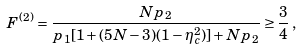<formula> <loc_0><loc_0><loc_500><loc_500>F ^ { ( 2 ) } = \frac { N p _ { 2 } } { p _ { 1 } [ 1 + ( 5 N - 3 ) ( 1 - \eta _ { c } ^ { 2 } ) ] + N p _ { 2 } } \geq \frac { 3 } { 4 } \, ,</formula> 